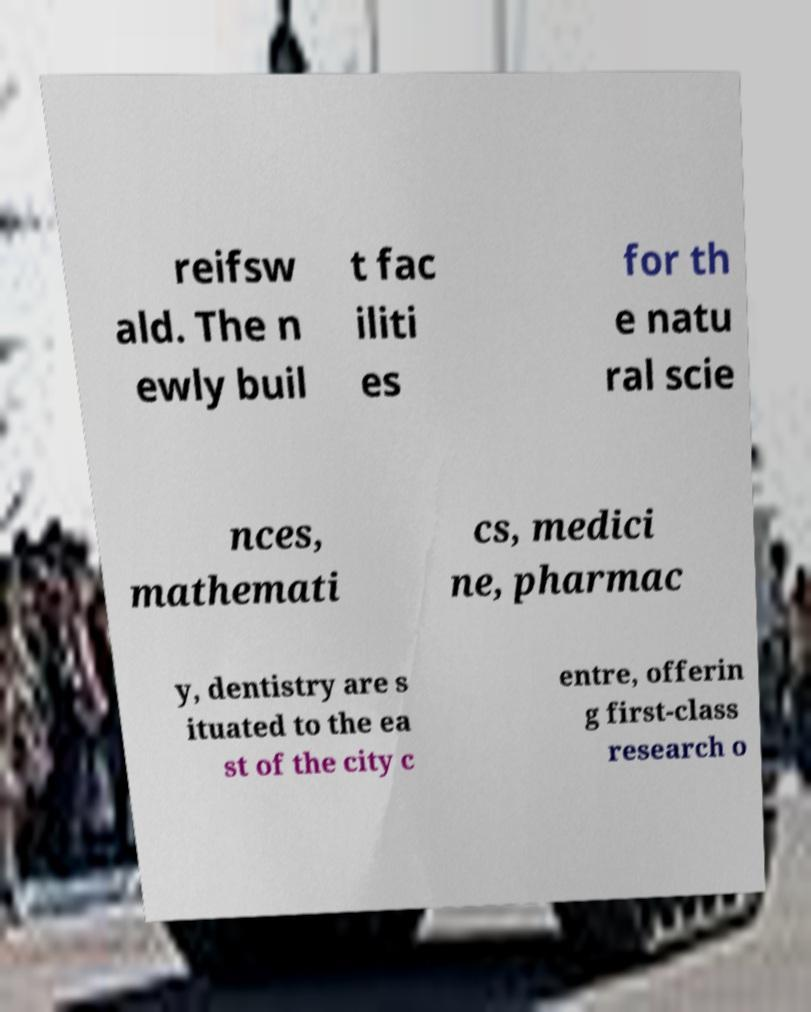Please identify and transcribe the text found in this image. reifsw ald. The n ewly buil t fac iliti es for th e natu ral scie nces, mathemati cs, medici ne, pharmac y, dentistry are s ituated to the ea st of the city c entre, offerin g first-class research o 